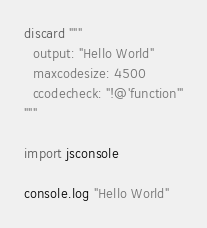<code> <loc_0><loc_0><loc_500><loc_500><_Nim_>discard """
  output: "Hello World"
  maxcodesize: 4500
  ccodecheck: "!@'function'"
"""

import jsconsole

console.log "Hello World"
</code> 